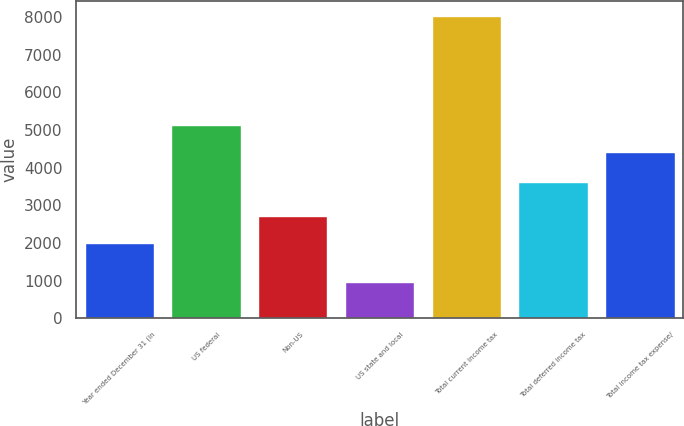<chart> <loc_0><loc_0><loc_500><loc_500><bar_chart><fcel>Year ended December 31 (in<fcel>US federal<fcel>Non-US<fcel>US state and local<fcel>Total current income tax<fcel>Total deferred income tax<fcel>Total income tax expense/<nl><fcel>2009<fcel>5121.6<fcel>2715.6<fcel>971<fcel>8037<fcel>3622<fcel>4415<nl></chart> 